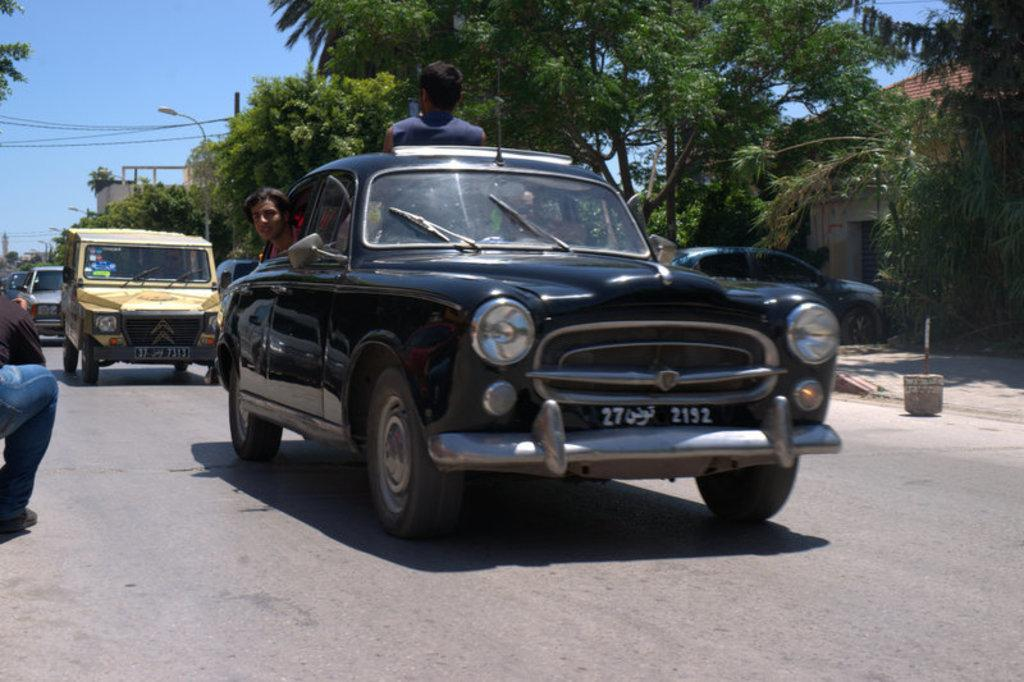What type of vehicle are the people sitting in? The people are sitting in a black car. How many cars can be seen behind the black car? There are many cars behind the black car. What is visible in the surroundings of the cars? There are trees around the cars. What type of notebook is lying on the hood of the black car? There is no notebook present on the hood of the black car in the image. 